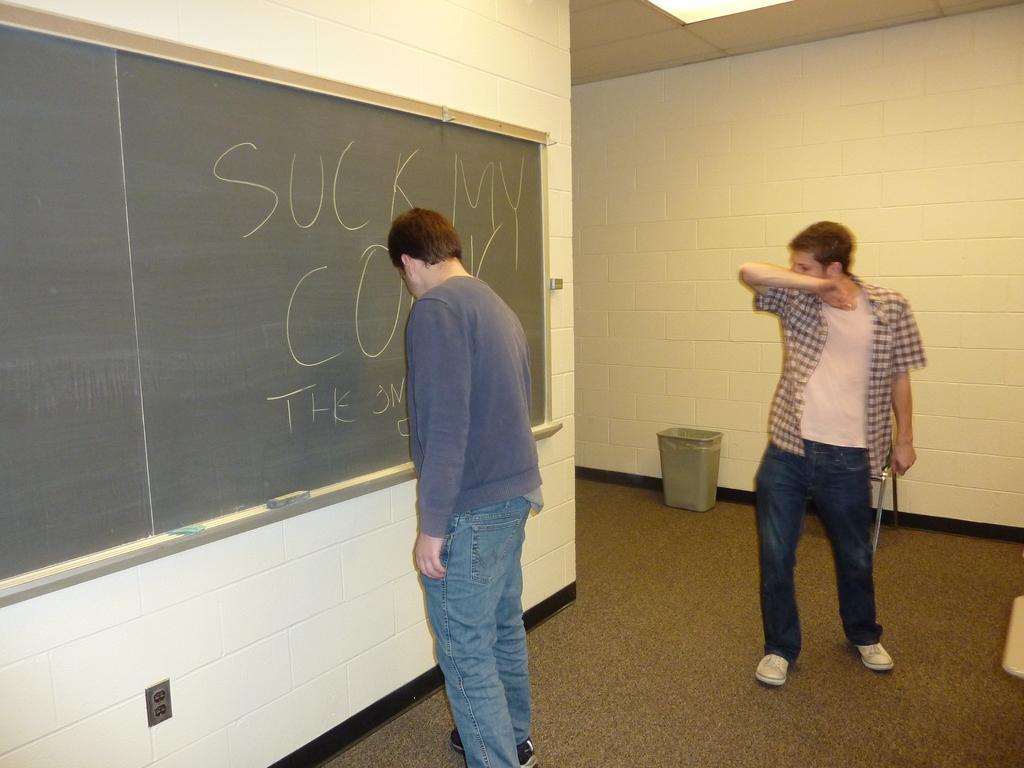Please provide a concise description of this image. In this image there is a person writing on the blackboard. Behind him there is another person standing on the floor and he is holding some object. In the background of the image there is a wall. There is a dustbin. On top of the image there is a light. 